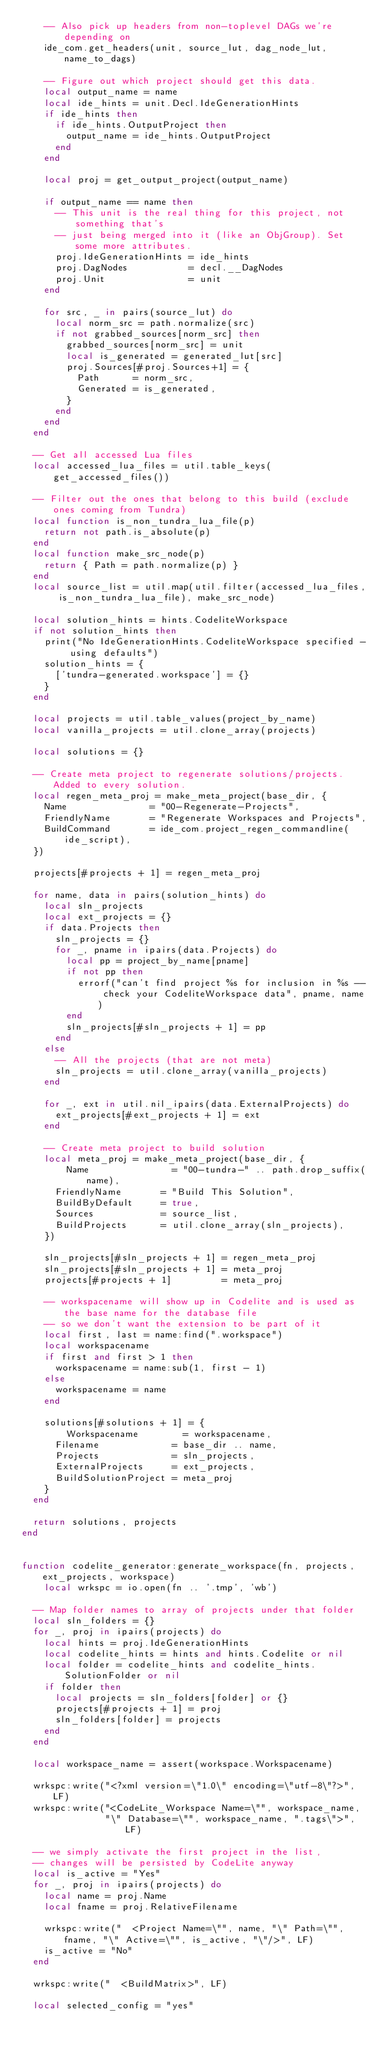<code> <loc_0><loc_0><loc_500><loc_500><_Lua_>    -- Also pick up headers from non-toplevel DAGs we're depending on
    ide_com.get_headers(unit, source_lut, dag_node_lut, name_to_dags)

    -- Figure out which project should get this data.
    local output_name = name
    local ide_hints = unit.Decl.IdeGenerationHints
    if ide_hints then
      if ide_hints.OutputProject then
        output_name = ide_hints.OutputProject
      end
    end

    local proj = get_output_project(output_name)

    if output_name == name then
      -- This unit is the real thing for this project, not something that's
      -- just being merged into it (like an ObjGroup). Set some more attributes.
      proj.IdeGenerationHints = ide_hints
      proj.DagNodes           = decl.__DagNodes
      proj.Unit               = unit
    end

    for src, _ in pairs(source_lut) do
      local norm_src = path.normalize(src)
      if not grabbed_sources[norm_src] then
        grabbed_sources[norm_src] = unit
        local is_generated = generated_lut[src]
        proj.Sources[#proj.Sources+1] = {
          Path      = norm_src,
          Generated = is_generated,
        }
      end
    end
  end

  -- Get all accessed Lua files
  local accessed_lua_files = util.table_keys(get_accessed_files())

  -- Filter out the ones that belong to this build (exclude ones coming from Tundra) 
  local function is_non_tundra_lua_file(p)
    return not path.is_absolute(p)
  end
  local function make_src_node(p)
    return { Path = path.normalize(p) }
  end
  local source_list = util.map(util.filter(accessed_lua_files, is_non_tundra_lua_file), make_src_node)

  local solution_hints = hints.CodeliteWorkspace
  if not solution_hints then
    print("No IdeGenerationHints.CodeliteWorkspace specified - using defaults")
    solution_hints = {
      ['tundra-generated.workspace'] = {}
    }
  end

  local projects = util.table_values(project_by_name)
  local vanilla_projects = util.clone_array(projects)

  local solutions = {}

  -- Create meta project to regenerate solutions/projects. Added to every solution.
  local regen_meta_proj = make_meta_project(base_dir, {
    Name               = "00-Regenerate-Projects",
    FriendlyName       = "Regenerate Workspaces and Projects",
    BuildCommand       = ide_com.project_regen_commandline(ide_script),
  })

  projects[#projects + 1] = regen_meta_proj

  for name, data in pairs(solution_hints) do
    local sln_projects
    local ext_projects = {}
    if data.Projects then
      sln_projects = {}
      for _, pname in ipairs(data.Projects) do
        local pp = project_by_name[pname]
        if not pp then
          errorf("can't find project %s for inclusion in %s -- check your CodeliteWorkspace data", pname, name)
        end
        sln_projects[#sln_projects + 1] = pp
      end
    else
      -- All the projects (that are not meta)
      sln_projects = util.clone_array(vanilla_projects)
    end

    for _, ext in util.nil_ipairs(data.ExternalProjects) do
      ext_projects[#ext_projects + 1] = ext
    end

    -- Create meta project to build solution
    local meta_proj = make_meta_project(base_dir, {
        Name               = "00-tundra-" .. path.drop_suffix(name),
      FriendlyName       = "Build This Solution",
      BuildByDefault     = true,
      Sources            = source_list,
      BuildProjects      = util.clone_array(sln_projects),
    })

    sln_projects[#sln_projects + 1] = regen_meta_proj
    sln_projects[#sln_projects + 1] = meta_proj
    projects[#projects + 1]         = meta_proj

    -- workspacename will show up in Codelite and is used as the base name for the database file
    -- so we don't want the extension to be part of it
    local first, last = name:find(".workspace")
    local workspacename
    if first and first > 1 then
      workspacename = name:sub(1, first - 1)
    else
      workspacename = name
    end

    solutions[#solutions + 1] = {
        Workspacename        = workspacename,
      Filename             = base_dir .. name,
      Projects             = sln_projects,
      ExternalProjects     = ext_projects,
      BuildSolutionProject = meta_proj
    }
  end

  return solutions, projects
end


function codelite_generator:generate_workspace(fn, projects, ext_projects, workspace)
    local wrkspc = io.open(fn .. '.tmp', 'wb')

  -- Map folder names to array of projects under that folder
  local sln_folders = {}
  for _, proj in ipairs(projects) do
    local hints = proj.IdeGenerationHints
    local codelite_hints = hints and hints.Codelite or nil
    local folder = codelite_hints and codelite_hints.SolutionFolder or nil
    if folder then
      local projects = sln_folders[folder] or {}
      projects[#projects + 1] = proj
      sln_folders[folder] = projects
    end
  end

  local workspace_name = assert(workspace.Workspacename)

  wrkspc:write("<?xml version=\"1.0\" encoding=\"utf-8\"?>", LF)
  wrkspc:write("<CodeLite_Workspace Name=\"", workspace_name,
               "\" Database=\"", workspace_name, ".tags\">", LF)

  -- we simply activate the first project in the list,
  -- changes will be persisted by CodeLite anyway
  local is_active = "Yes"
  for _, proj in ipairs(projects) do
    local name = proj.Name
    local fname = proj.RelativeFilename

    wrkspc:write("  <Project Name=\"", name, "\" Path=\"", fname, "\" Active=\"", is_active, "\"/>", LF)
    is_active = "No"
  end

  wrkspc:write("  <BuildMatrix>", LF) 

  local selected_config = "yes"
</code> 